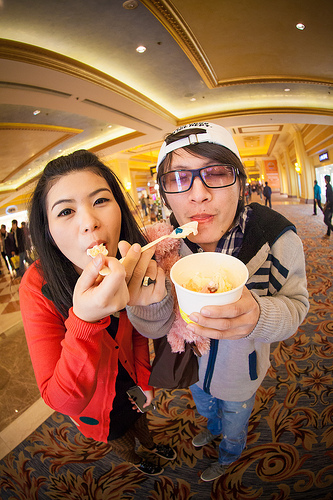<image>
Can you confirm if the glasses is on the girl? No. The glasses is not positioned on the girl. They may be near each other, but the glasses is not supported by or resting on top of the girl. Is there a lady in the dress? Yes. The lady is contained within or inside the dress, showing a containment relationship. Where is the spoon in relation to the cup? Is it in the cup? No. The spoon is not contained within the cup. These objects have a different spatial relationship. 